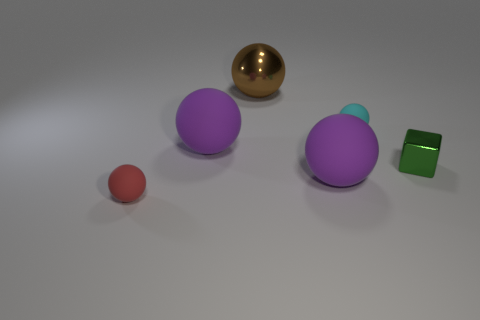Subtract 2 balls. How many balls are left? 3 Subtract all red balls. How many balls are left? 4 Subtract all tiny red balls. How many balls are left? 4 Subtract all blue spheres. Subtract all green blocks. How many spheres are left? 5 Add 4 green rubber spheres. How many objects exist? 10 Subtract all cubes. How many objects are left? 5 Subtract all gray spheres. Subtract all red matte spheres. How many objects are left? 5 Add 2 large matte balls. How many large matte balls are left? 4 Add 2 red rubber spheres. How many red rubber spheres exist? 3 Subtract 1 green cubes. How many objects are left? 5 